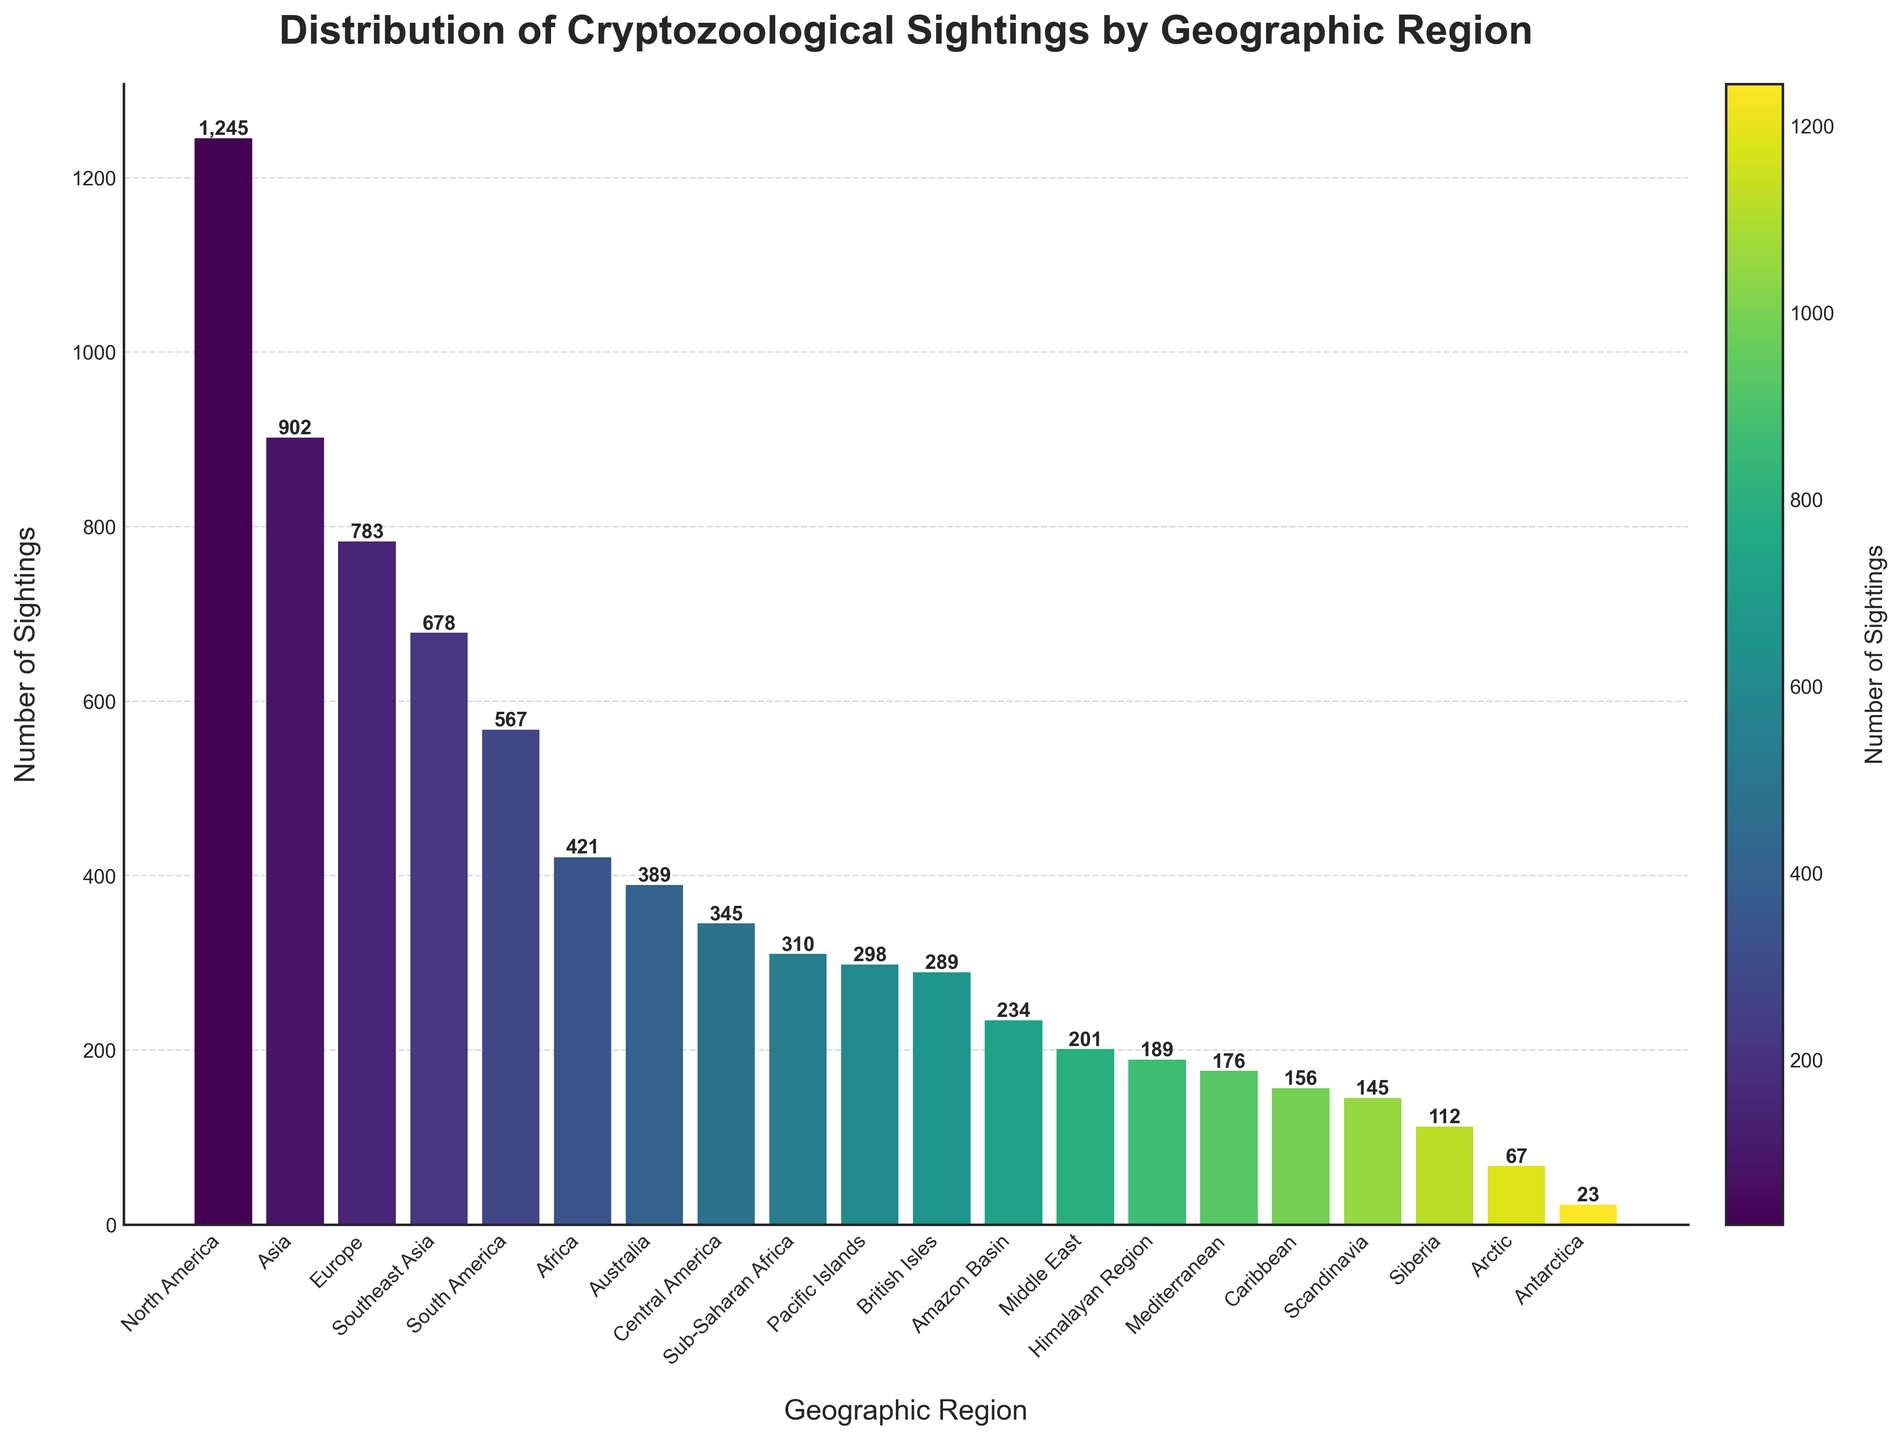What are the top three regions with the highest number of cryptozoological sightings? To identify the top three regions, look at the three tallest bars in the bar chart. From the sorted visual representation, the regions with the highest sightings should be easily identifiable.
Answer: North America, Asia, Europe Which region has the least number of sightings, and how many are there? Identify the shortest bar in the chart. The label of that bar will be the region with the least sightings, and the height of the bar will indicate the number.
Answer: Antarctica, 23 Is there a significant difference between the sightings in Europe and Asia? Compare the heights of the bars for Europe and Asia. Asia's bar is taller than Europe's, indicating more sightings in Asia. Subtract the number of sightings in Europe from that in Asia to find the difference.
Answer: Yes, 119 Which regions have sightings in the range of 200 to 300? Look for the bars whose heights are between 200 and 300. Identify the regions represented by these bars.
Answer: Middle East, Pacific Islands, Amazon Basin, British Isles What is the cumulative number of sightings in Southeast Asia and the Caribbean? Find the bar heights (or values) for Southeast Asia and the Caribbean. Add these two numbers together to find the total number of sightings in both regions.
Answer: 834 How does the number of sightings in the Arctic compare with the Mediterranean? Compare the heights of the bars labeled Arctic and Mediterranean. Note whether the Arctic's value is greater or lesser than the Mediterranean's, or if they are equal.
Answer: Less, 67 vs 176 What color is used to represent the region with the highest number of sightings? Identify the tallest bar, which represents the region with the highest number of sightings. Observe the color of this bar as indicated by the colormap used in the figure.
Answer: Dark green What is the average number of sightings across all the regions shown? Sum all the sightings from each region and divide by the total number of regions (20). The total sightings are noted and divided by the number of regions to find the average.
Answer: 382 How many more sightings does North America have compared to Africa? Find the heights of the bars for North America and Africa. Subtract the sightings in Africa from those in North America to find the difference.
Answer: 824 What is the median number of sightings among all regions? Arrange all the sightings in ascending order and find the middle value(s). Since there are 20 regions, take the average of the 10th and 11th values.
Answer: 298 